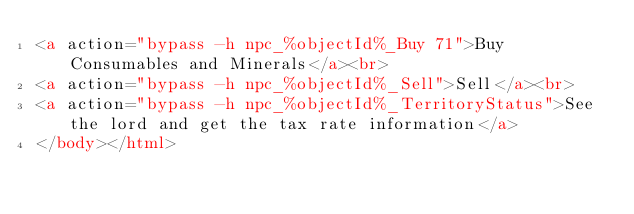<code> <loc_0><loc_0><loc_500><loc_500><_HTML_><a action="bypass -h npc_%objectId%_Buy 71">Buy Consumables and Minerals</a><br>
<a action="bypass -h npc_%objectId%_Sell">Sell</a><br>
<a action="bypass -h npc_%objectId%_TerritoryStatus">See the lord and get the tax rate information</a>
</body></html></code> 